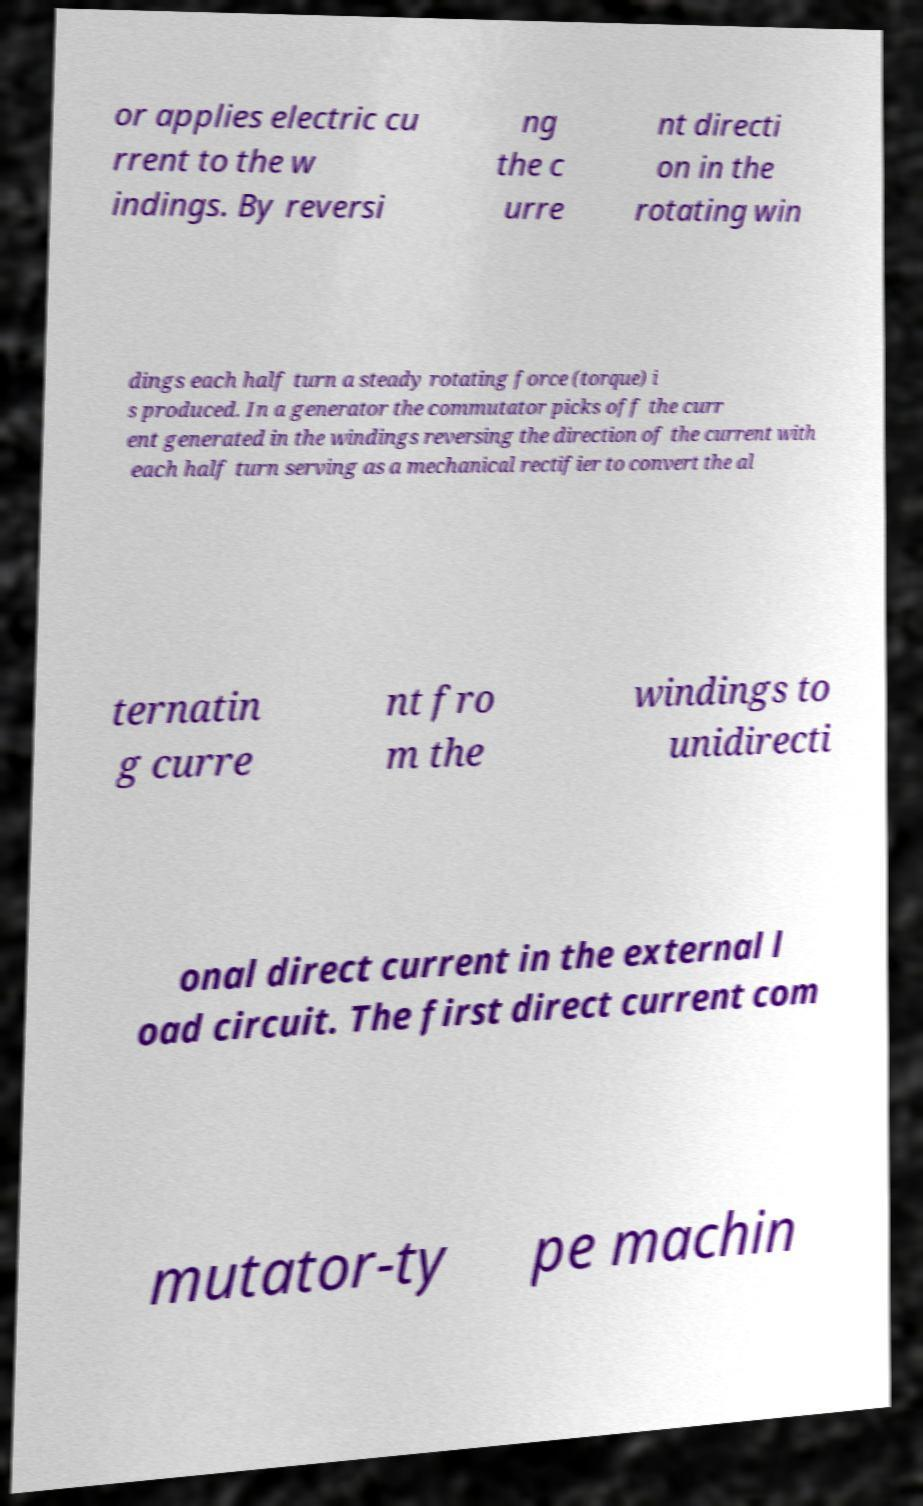Can you read and provide the text displayed in the image?This photo seems to have some interesting text. Can you extract and type it out for me? or applies electric cu rrent to the w indings. By reversi ng the c urre nt directi on in the rotating win dings each half turn a steady rotating force (torque) i s produced. In a generator the commutator picks off the curr ent generated in the windings reversing the direction of the current with each half turn serving as a mechanical rectifier to convert the al ternatin g curre nt fro m the windings to unidirecti onal direct current in the external l oad circuit. The first direct current com mutator-ty pe machin 